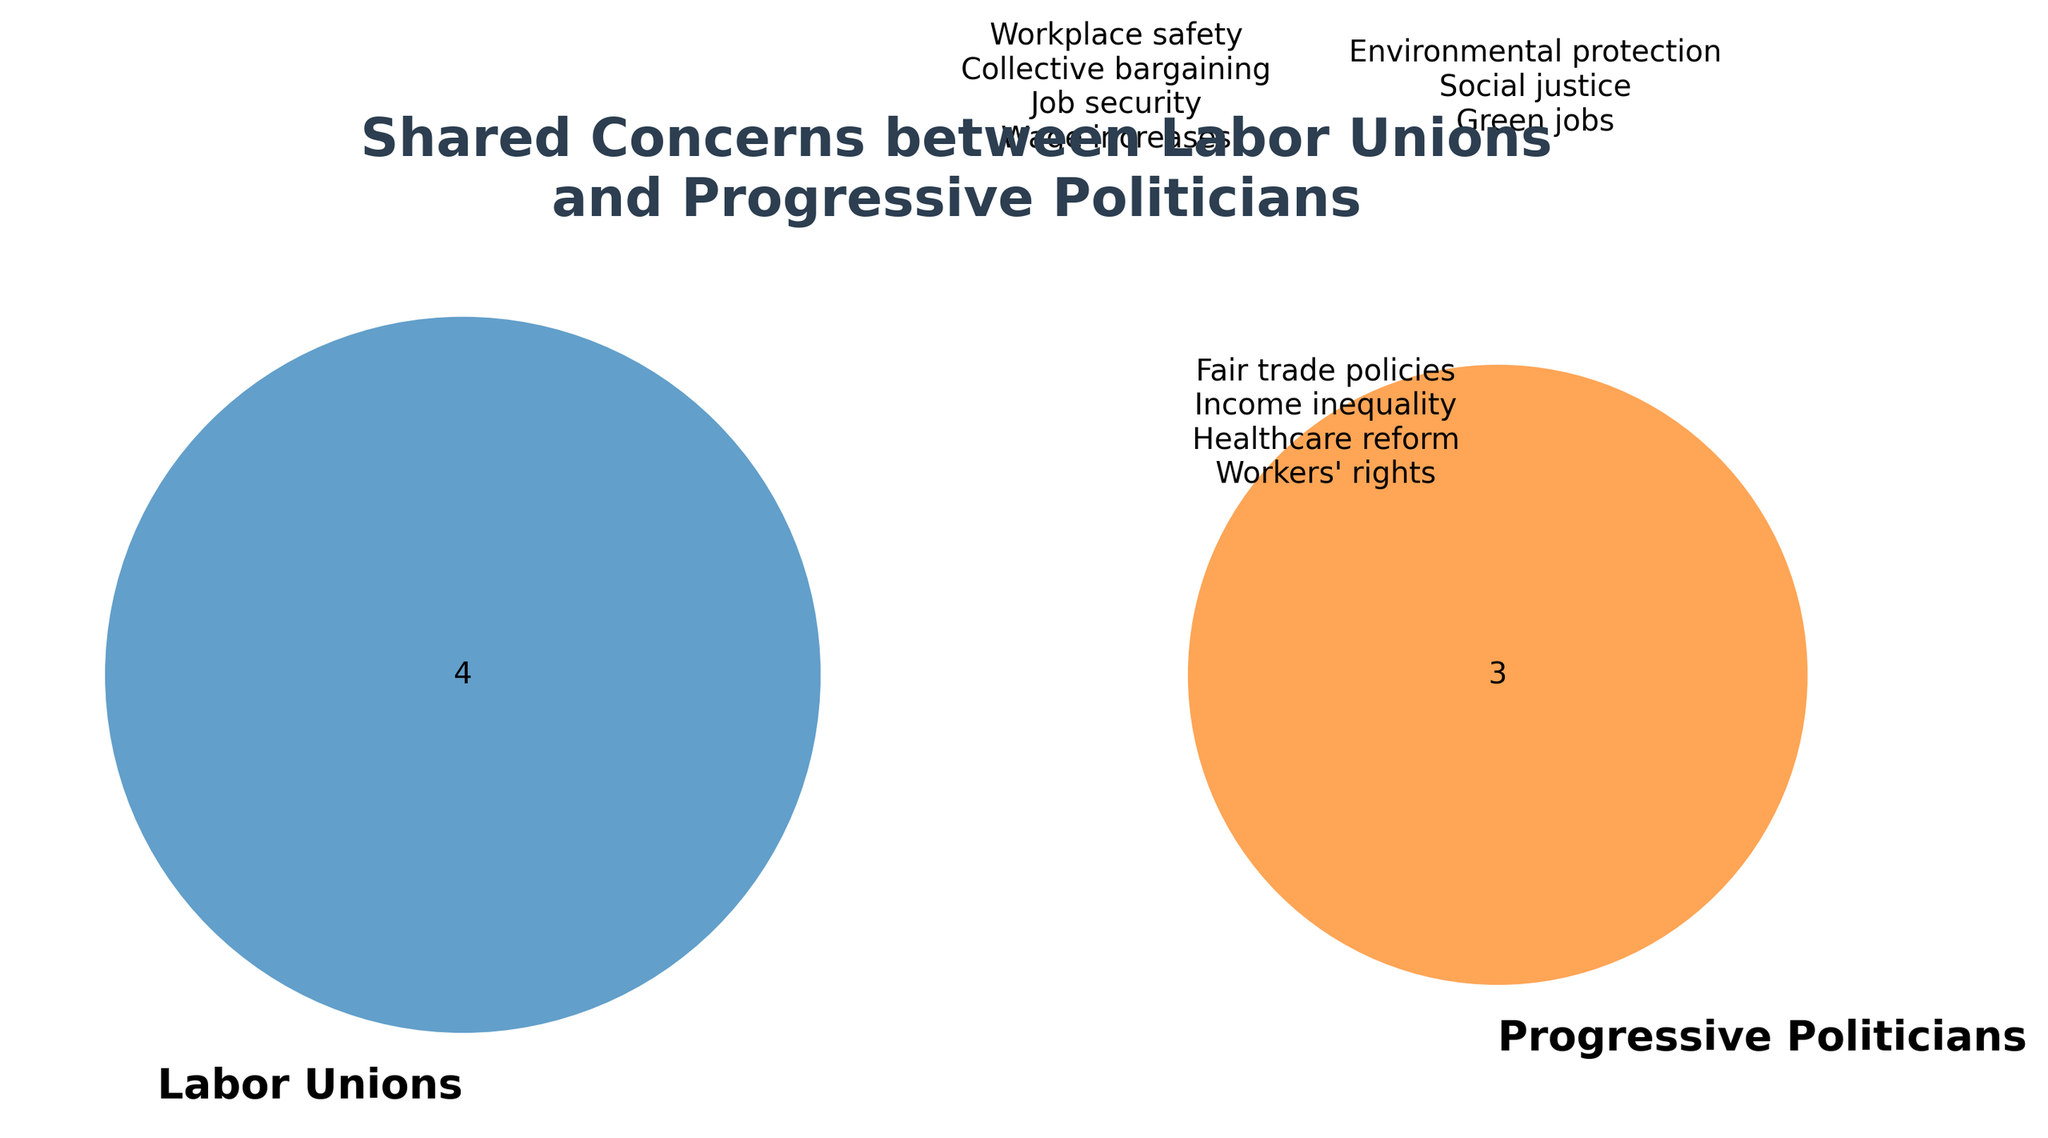what is the title of the figure? The title can be seen at the top of the figure. It is written in bold and large font.
Answer: Shared Concerns between Labor Unions and Progressive Politicians What appears in the overlapping section of the Venn diagram? The overlapping section represents shared concerns between labor unions and progressive politicians. By checking this section, you see "workers' rights," "healthcare reform," "income inequality," and "fair trade policies."
Answer: Workers' rights, healthcare reform, income inequality, fair trade policies Which concerns are exclusive to labor unions? By looking at the left non-overlapping section of the Venn diagram, you can see the concerns exclusive to labor unions.
Answer: Wage increases, workplace safety, collective bargaining, job security Which concerns are exclusive to progressive politicians? Look at the right non-overlapping section of the Venn diagram to find the concerns exclusive to progressive politicians.
Answer: Environmental protection, social justice, green jobs Is job security a shared concern? Job security can be found in the left circle under labor unions. It does not appear in the overlapping section. This means it is not a shared concern.
Answer: No Which group has more exclusive concerns? Labor unions have four exclusive concerns (wage increases, workplace safety, collective bargaining, job security) while progressive politicians have three (environmental protection, social justice, green jobs). Count these items to compare the numbers.
Answer: Labor unions Count the total number of shared concerns. The total number of shared concerns can be found by counting the items in the overlapping section of the Venn diagram. These are workers' rights, healthcare reform, income inequality, and fair trade policies, which gives a total of 4.
Answer: 4 List two concerns that labor unions care about but progressive politicians do not. Look at the left non-overlapping section of the diagram. Any two concerns from there can be chosen.
Answer: Wage increases, collective bargaining Which group's unique concerns align with environmental protection? Environmental protection is in the right non-overlapping section, indicating it is a specific concern of progressive politicians.
Answer: Progressive politicians 